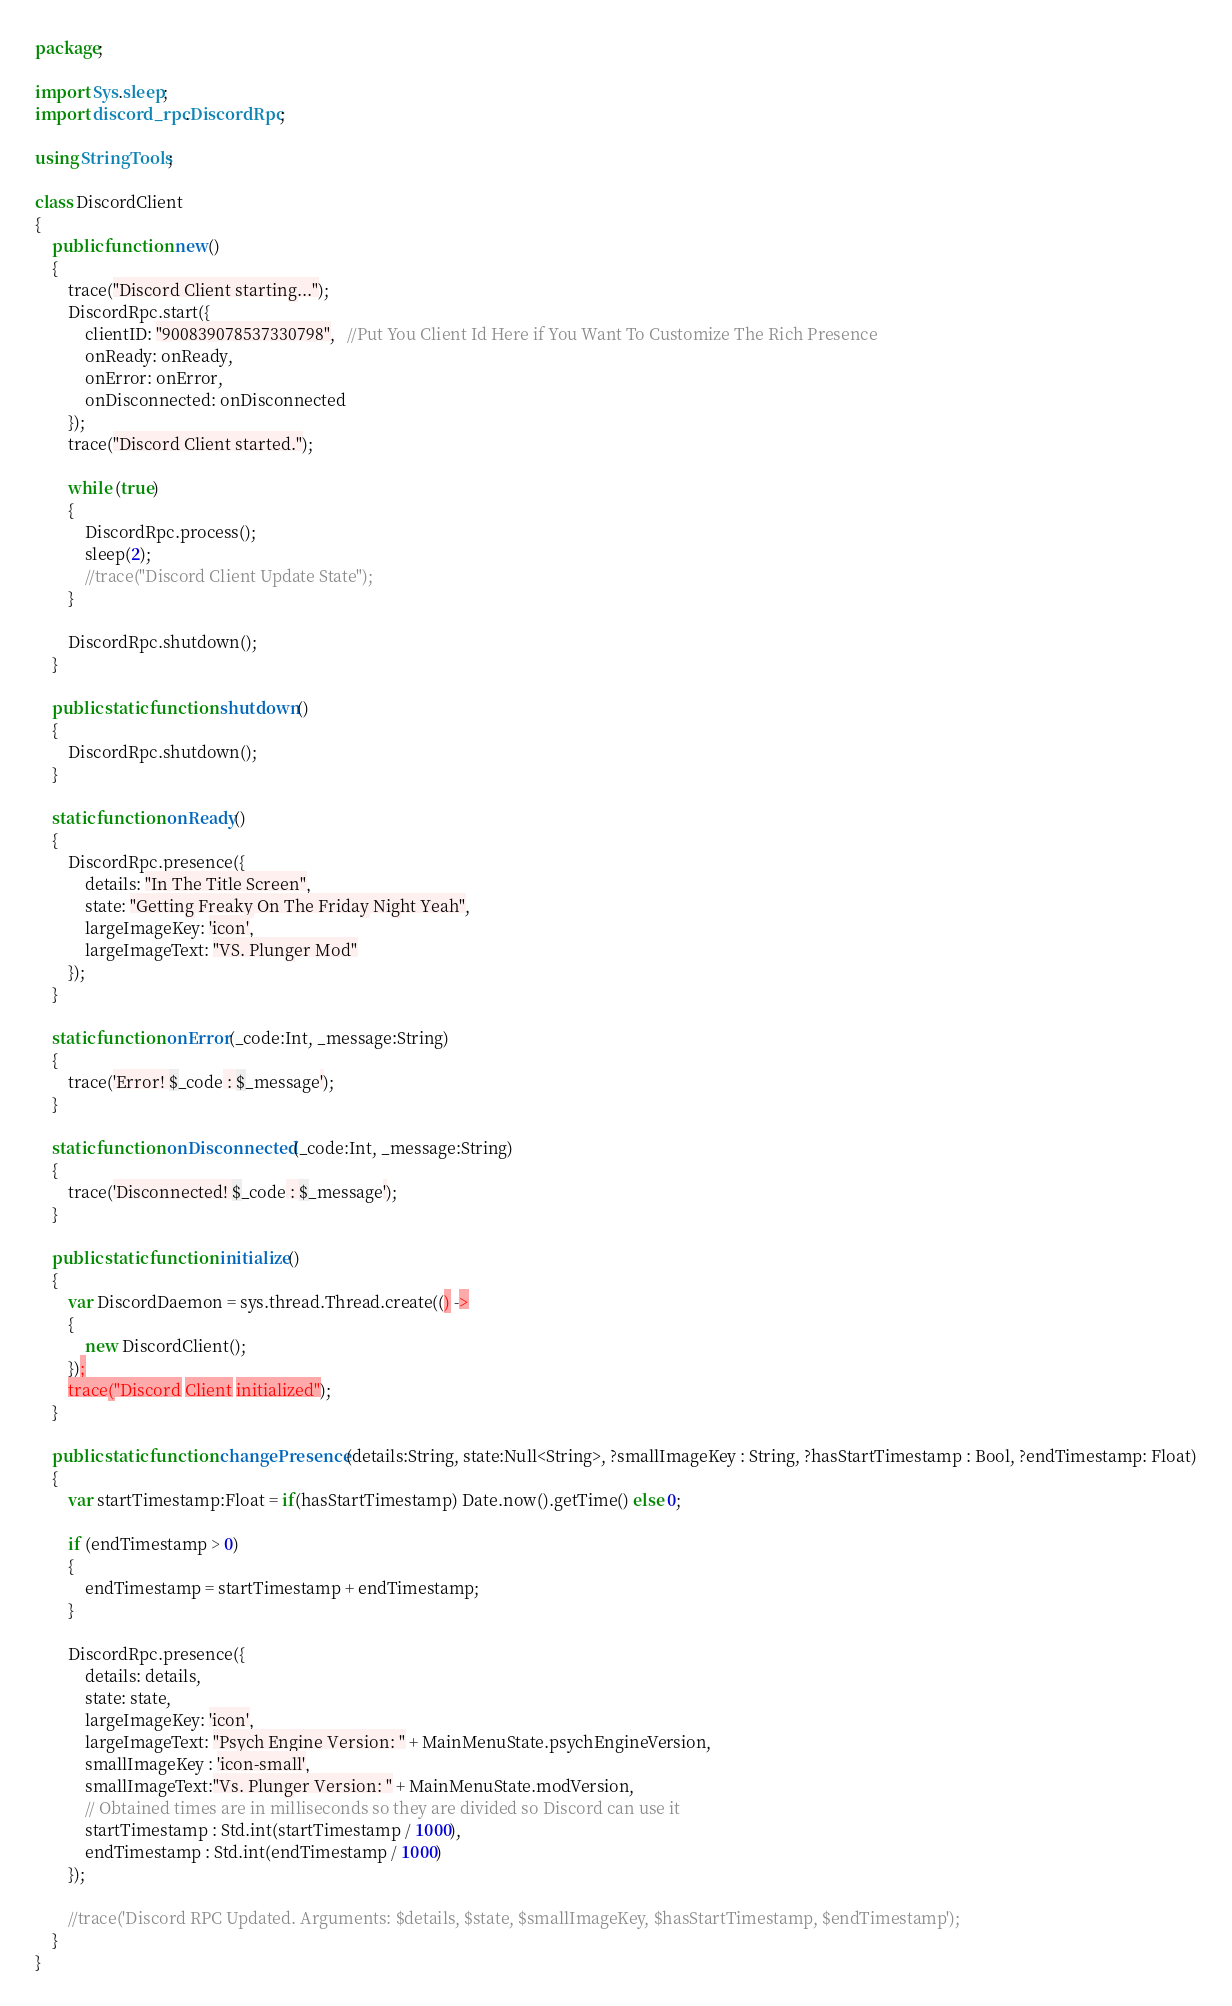Convert code to text. <code><loc_0><loc_0><loc_500><loc_500><_Haxe_>package;

import Sys.sleep;
import discord_rpc.DiscordRpc;

using StringTools;

class DiscordClient
{
	public function new()
	{
		trace("Discord Client starting...");
		DiscordRpc.start({
			clientID: "900839078537330798",   //Put You Client Id Here if You Want To Customize The Rich Presence
			onReady: onReady,
			onError: onError,
			onDisconnected: onDisconnected
		});
		trace("Discord Client started.");

		while (true)
		{
			DiscordRpc.process();
			sleep(2);
			//trace("Discord Client Update State");
		}

		DiscordRpc.shutdown();
	}
	
	public static function shutdown()
	{
		DiscordRpc.shutdown();
	}
	
	static function onReady()
	{
		DiscordRpc.presence({
			details: "In The Title Screen",
			state: "Getting Freaky On The Friday Night Yeah",
			largeImageKey: 'icon',
			largeImageText: "VS. Plunger Mod"
		});
	}

	static function onError(_code:Int, _message:String)
	{
		trace('Error! $_code : $_message');
	}

	static function onDisconnected(_code:Int, _message:String)
	{
		trace('Disconnected! $_code : $_message');
	}

	public static function initialize()
	{
		var DiscordDaemon = sys.thread.Thread.create(() ->
		{
			new DiscordClient();
		});
		trace("Discord Client initialized");
	}

	public static function changePresence(details:String, state:Null<String>, ?smallImageKey : String, ?hasStartTimestamp : Bool, ?endTimestamp: Float)
	{
		var startTimestamp:Float = if(hasStartTimestamp) Date.now().getTime() else 0;

		if (endTimestamp > 0)
		{
			endTimestamp = startTimestamp + endTimestamp;
		}

		DiscordRpc.presence({
			details: details,
			state: state,
			largeImageKey: 'icon',
			largeImageText: "Psych Engine Version: " + MainMenuState.psychEngineVersion,
			smallImageKey : 'icon-small',
			smallImageText:"Vs. Plunger Version: " + MainMenuState.modVersion,
			// Obtained times are in milliseconds so they are divided so Discord can use it
			startTimestamp : Std.int(startTimestamp / 1000),
            endTimestamp : Std.int(endTimestamp / 1000)
		});

		//trace('Discord RPC Updated. Arguments: $details, $state, $smallImageKey, $hasStartTimestamp, $endTimestamp');
	}
}
</code> 